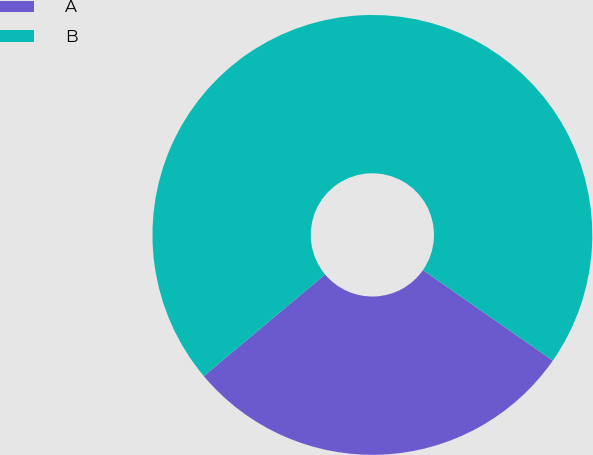Convert chart to OTSL. <chart><loc_0><loc_0><loc_500><loc_500><pie_chart><fcel>A<fcel>B<nl><fcel>29.22%<fcel>70.78%<nl></chart> 